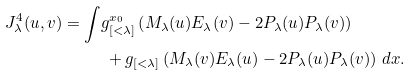Convert formula to latex. <formula><loc_0><loc_0><loc_500><loc_500>J ^ { 4 } _ { \lambda } ( u , v ) = \int & g _ { [ < \lambda ] } ^ { x _ { 0 } } \left ( M _ { \lambda } ( u ) E _ { \lambda } ( v ) - 2 P _ { \lambda } ( u ) P _ { \lambda } ( v ) \right ) \\ & \ + g _ { [ < \lambda ] } \left ( M _ { \lambda } ( v ) E _ { \lambda } ( u ) - 2 P _ { \lambda } ( u ) P _ { \lambda } ( v ) \right ) \, d x .</formula> 